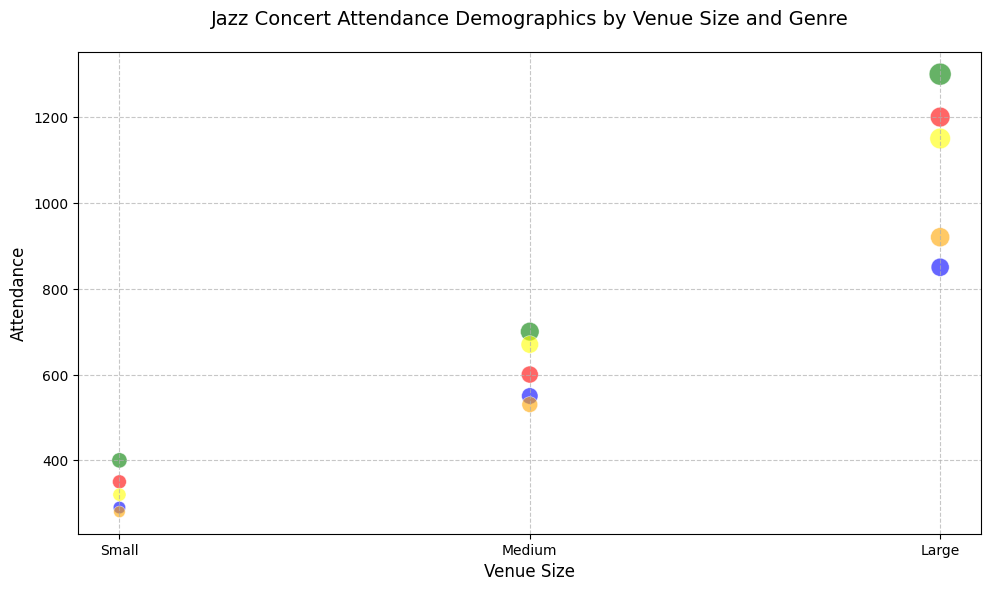What genre has the highest attendance in large venues? Looking at the large venue bubbles, the green bubble representing Latin Jazz has the highest attendance, surpassing all other colored bubbles.
Answer: Latin Jazz Which genre has the smallest attendance difference between small and large venues? By calculating the attendance difference for each genre between small and large venues: Traditional Jazz (1200-350=850), Modern Jazz (850-290=560), Latin Jazz (1300-400=900), Smooth Jazz (1150-320=830), and Fusion Jazz (920-280=640). The smallest difference is for Modern Jazz.
Answer: Modern Jazz For medium venues, how does the Fusion Jazz attendance compare to Smooth Jazz? Observing the medium venue bubbles, the orange bubble (Fusion Jazz, 530 attendees) is smaller than the yellow bubble (Smooth Jazz, 670 attendees).
Answer: Fusion Jazz has smaller attendance How many genres fall under the "Large" venue size? Counting the distinct bubbles for the "Large" category along the x-axis: Traditional Jazz (red), Modern Jazz (blue), Latin Jazz (green), Smooth Jazz (yellow), and Fusion Jazz (orange), there are five genres.
Answer: 5 For small venues, which genre draws the most attendees? Among the small venue bubbles, the green bubble (Latin Jazz) is the largest, showing it has the highest attendance.
Answer: Latin Jazz What is the average attendance for Smooth Jazz across all venue sizes? The Smooth Jazz attendance data points are 320 (Small), 670 (Medium), and 1150 (Large). The average is calculated as (320+670+1150)/3 = 2140/3 ≈ 713.33.
Answer: ≈ 713 Compare the attendance of Traditional Jazz in medium and large venues. Looking at the y-axis values: Traditional Jazz has 600 attendees in medium venues and 1200 in large venues. The attendance in large venues is twice that in medium venues.
Answer: Large is twice Medium Which genre in medium venues has the largest bubble size? Observing the medium venue section, the green bubble (Latin Jazz) has the largest dimension among other genre bubbles.
Answer: Latin Jazz Does the attendance for Fusion Jazz increase consistently with the venue size? The attendance for Fusion Jazz grows as venue size increases: Small (280), Medium (530), and Large (920). The trend shows a consistent increase.
Answer: Yes What color represents the genre with the highest average attendance across all venue sizes? Calculate the average attendance for each genre: 
- Traditional Jazz: (350+600+1200)/3 = 717
- Modern Jazz: (290+550+850)/3 = 563.33
- Latin Jazz: (400+700+1300)/3 = 800
- Smooth Jazz: (320+670+1150)/3 = 713.33
- Fusion Jazz: (280+530+920)/3 = 576.67
Latin Jazz has the highest average attendance, and the color is green.
Answer: Green 